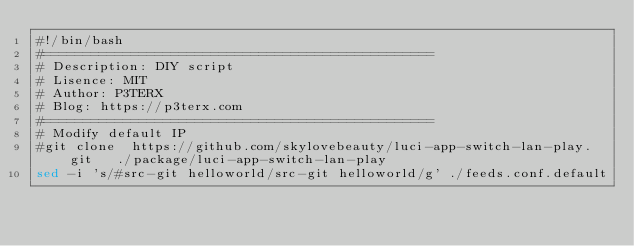Convert code to text. <code><loc_0><loc_0><loc_500><loc_500><_Bash_>#!/bin/bash
#=================================================
# Description: DIY script
# Lisence: MIT
# Author: P3TERX
# Blog: https://p3terx.com
#=================================================
# Modify default IP
#git clone  https://github.com/skylovebeauty/luci-app-switch-lan-play.git   ./package/luci-app-switch-lan-play
sed -i 's/#src-git helloworld/src-git helloworld/g' ./feeds.conf.default</code> 